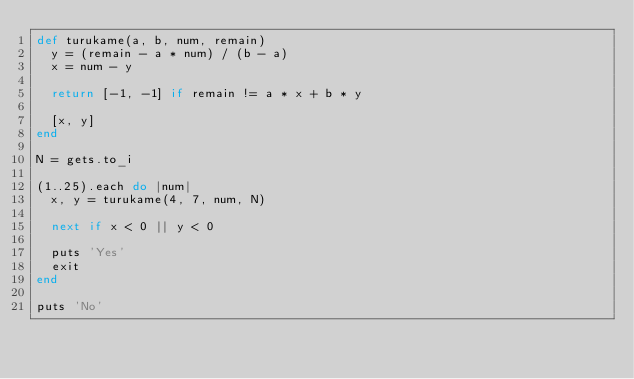<code> <loc_0><loc_0><loc_500><loc_500><_Ruby_>def turukame(a, b, num, remain)
  y = (remain - a * num) / (b - a)
  x = num - y

  return [-1, -1] if remain != a * x + b * y

  [x, y]
end

N = gets.to_i

(1..25).each do |num|
  x, y = turukame(4, 7, num, N)

  next if x < 0 || y < 0

  puts 'Yes'
  exit
end

puts 'No'
</code> 